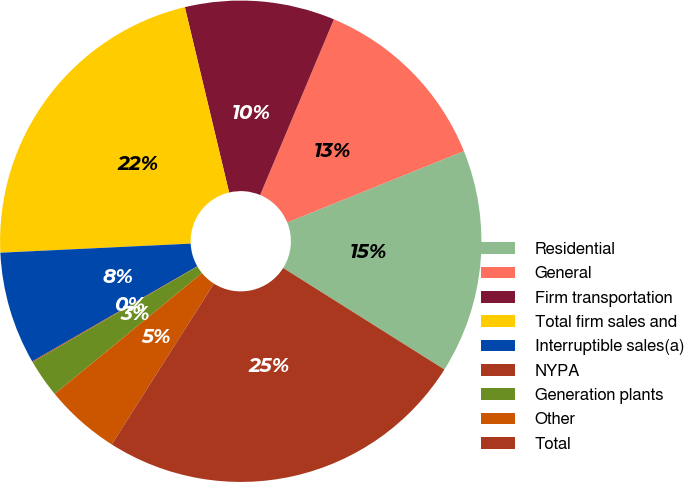Convert chart to OTSL. <chart><loc_0><loc_0><loc_500><loc_500><pie_chart><fcel>Residential<fcel>General<fcel>Firm transportation<fcel>Total firm sales and<fcel>Interruptible sales(a)<fcel>NYPA<fcel>Generation plants<fcel>Other<fcel>Total<nl><fcel>15.06%<fcel>12.56%<fcel>10.06%<fcel>22.03%<fcel>7.56%<fcel>0.06%<fcel>2.56%<fcel>5.06%<fcel>25.06%<nl></chart> 